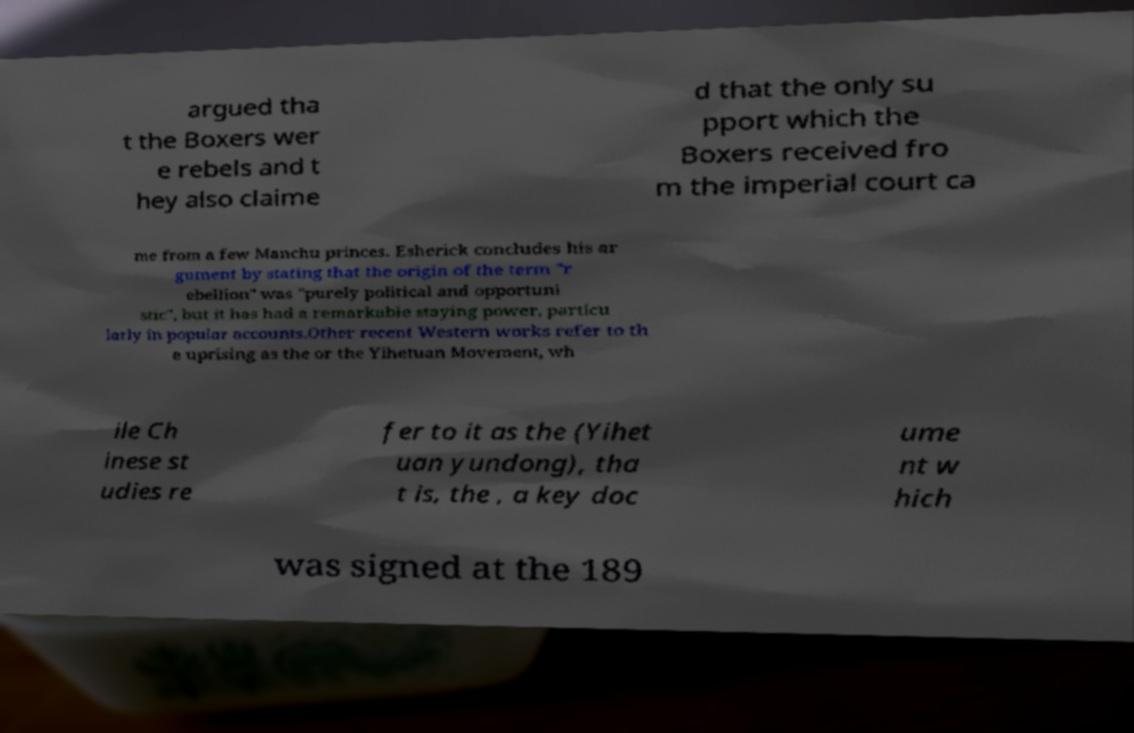I need the written content from this picture converted into text. Can you do that? argued tha t the Boxers wer e rebels and t hey also claime d that the only su pport which the Boxers received fro m the imperial court ca me from a few Manchu princes. Esherick concludes his ar gument by stating that the origin of the term "r ebellion" was "purely political and opportuni stic", but it has had a remarkable staying power, particu larly in popular accounts.Other recent Western works refer to th e uprising as the or the Yihetuan Movement, wh ile Ch inese st udies re fer to it as the (Yihet uan yundong), tha t is, the , a key doc ume nt w hich was signed at the 189 